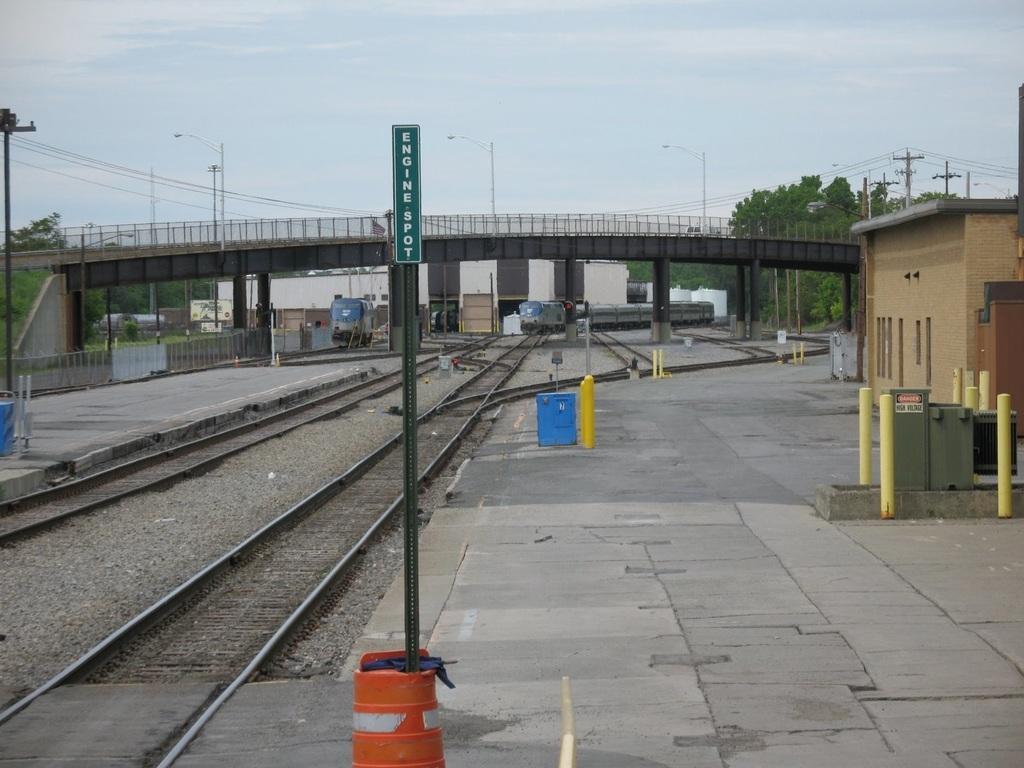How would you summarize this image in a sentence or two? In this picture there are tracks in the center of the image and there are trains in the image and there is a bridge at the top side of the image and there are poles and trees in the background area of the image and there are boundaries on the right and left side of the image and there is a pole in the center of the image. 